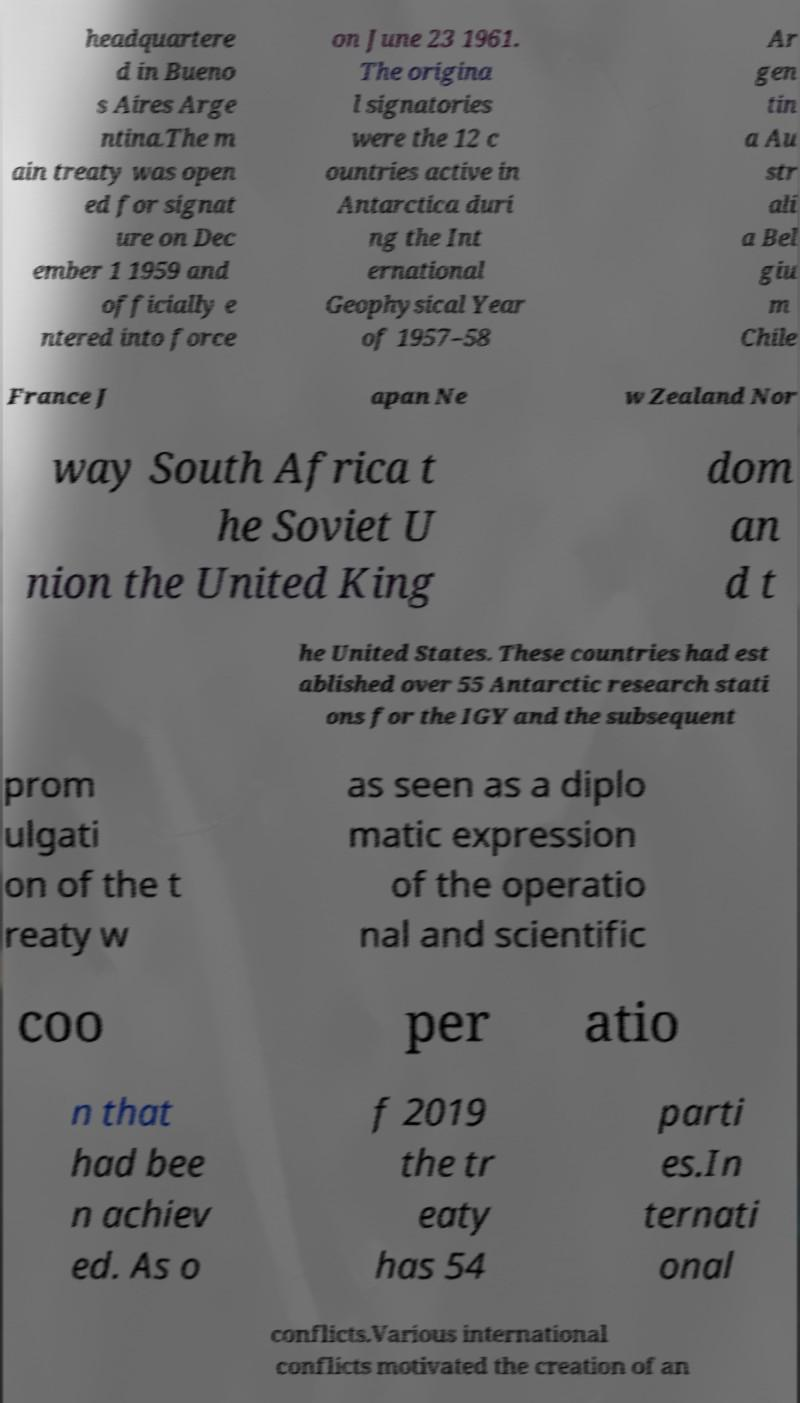Can you read and provide the text displayed in the image?This photo seems to have some interesting text. Can you extract and type it out for me? headquartere d in Bueno s Aires Arge ntina.The m ain treaty was open ed for signat ure on Dec ember 1 1959 and officially e ntered into force on June 23 1961. The origina l signatories were the 12 c ountries active in Antarctica duri ng the Int ernational Geophysical Year of 1957–58 Ar gen tin a Au str ali a Bel giu m Chile France J apan Ne w Zealand Nor way South Africa t he Soviet U nion the United King dom an d t he United States. These countries had est ablished over 55 Antarctic research stati ons for the IGY and the subsequent prom ulgati on of the t reaty w as seen as a diplo matic expression of the operatio nal and scientific coo per atio n that had bee n achiev ed. As o f 2019 the tr eaty has 54 parti es.In ternati onal conflicts.Various international conflicts motivated the creation of an 